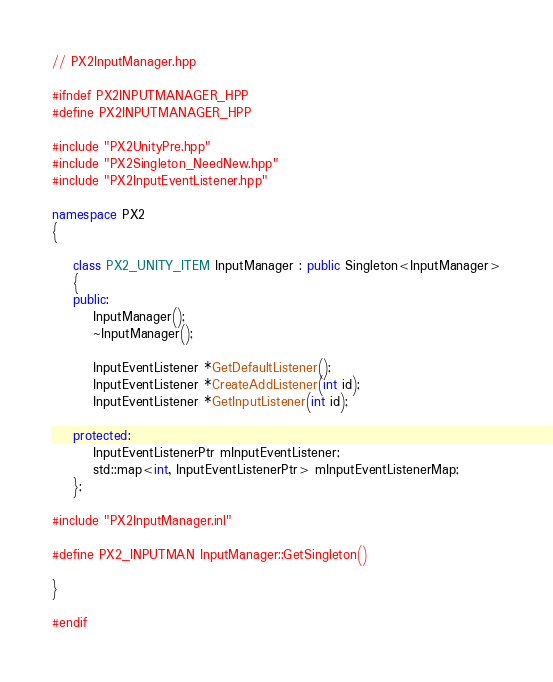<code> <loc_0><loc_0><loc_500><loc_500><_C++_>// PX2InputManager.hpp

#ifndef PX2INPUTMANAGER_HPP
#define PX2INPUTMANAGER_HPP

#include "PX2UnityPre.hpp"
#include "PX2Singleton_NeedNew.hpp"
#include "PX2InputEventListener.hpp"

namespace PX2
{

	class PX2_UNITY_ITEM InputManager : public Singleton<InputManager>
	{
	public:
		InputManager();
		~InputManager();

		InputEventListener *GetDefaultListener();
		InputEventListener *CreateAddListener(int id);
		InputEventListener *GetInputListener(int id);

	protected:
		InputEventListenerPtr mInputEventListener;
		std::map<int, InputEventListenerPtr> mInputEventListenerMap;
	};

#include "PX2InputManager.inl"

#define PX2_INPUTMAN InputManager::GetSingleton()

}

#endif</code> 